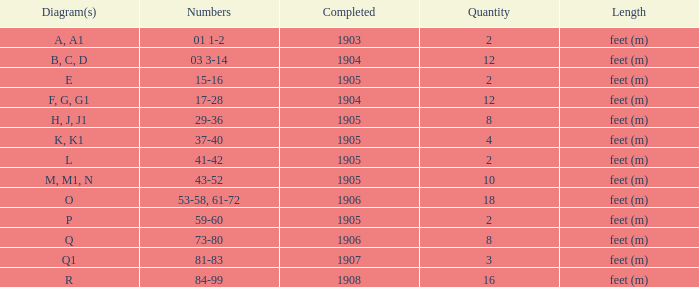For the item with more than 10, and numbers of 53-58, 61-72, what is the lowest completed? 1906.0. 